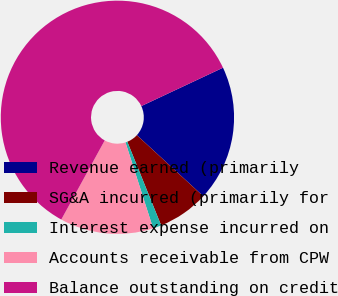Convert chart to OTSL. <chart><loc_0><loc_0><loc_500><loc_500><pie_chart><fcel>Revenue earned (primarily<fcel>SG&A incurred (primarily for<fcel>Interest expense incurred on<fcel>Accounts receivable from CPW<fcel>Balance outstanding on credit<nl><fcel>18.82%<fcel>7.05%<fcel>1.17%<fcel>12.94%<fcel>60.02%<nl></chart> 